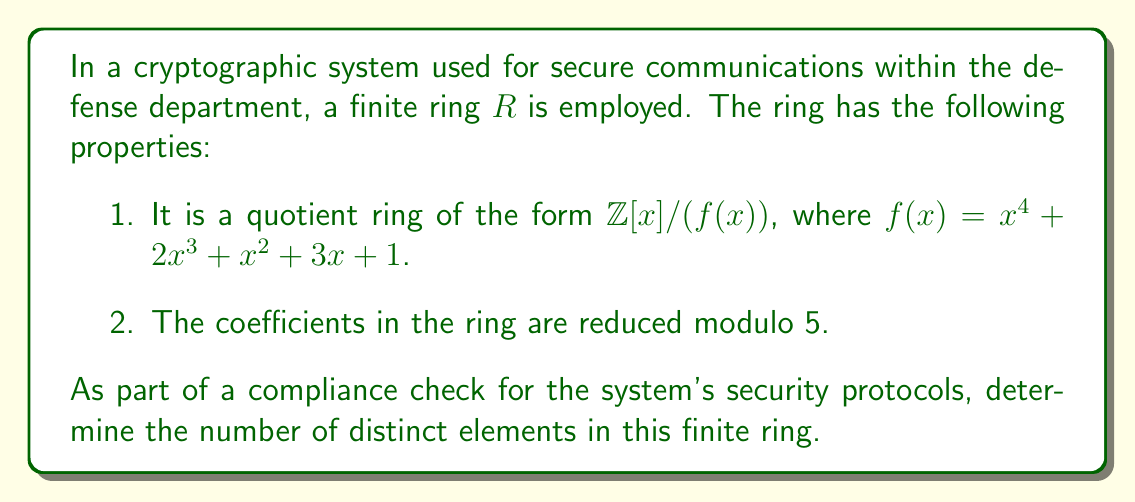Provide a solution to this math problem. To determine the number of distinct elements in the finite ring, we'll follow these steps:

1) The ring is of the form $R = \mathbb{Z}[x]/(f(x))$ where $f(x) = x^4 + 2x^3 + x^2 + 3x + 1$, and coefficients are reduced modulo 5.

2) In a quotient ring of this form, every element can be represented uniquely as a polynomial of degree less than the degree of $f(x)$, with coefficients from the base field (in this case, $\mathbb{Z}_5$).

3) The degree of $f(x)$ is 4, so every element in $R$ can be uniquely represented as:

   $ax^3 + bx^2 + cx + d$, where $a, b, c, d \in \mathbb{Z}_5$

4) To count the number of distinct elements, we need to count how many ways we can choose $a, b, c,$ and $d$.

5) For each of $a, b, c,$ and $d$, we have 5 choices (0, 1, 2, 3, or 4 in $\mathbb{Z}_5$).

6) By the multiplication principle, the total number of distinct elements is:

   $5 \cdot 5 \cdot 5 \cdot 5 = 5^4 = 625$

Therefore, the finite ring contains 625 distinct elements.
Answer: 625 